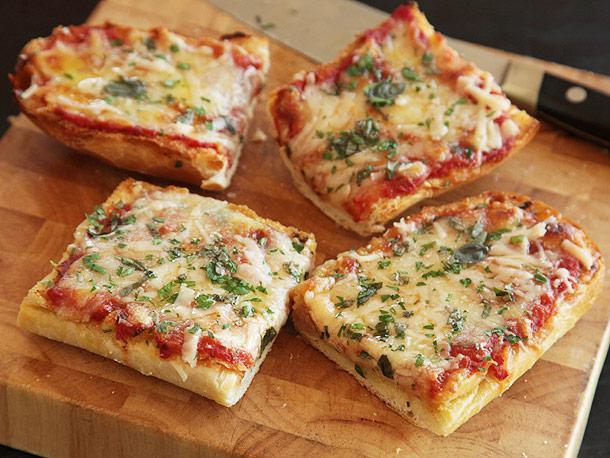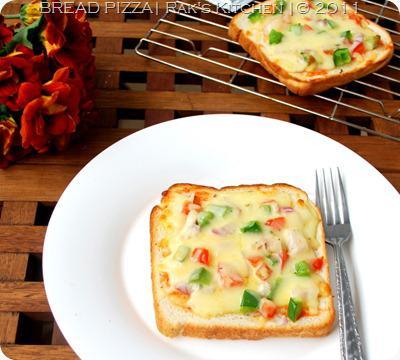The first image is the image on the left, the second image is the image on the right. Analyze the images presented: Is the assertion "One image shows four rectangles covered in red sauce, melted cheese, and green herbs on a wooden board, and the other image includes a topped slice of bread on a white plate." valid? Answer yes or no. Yes. The first image is the image on the left, the second image is the image on the right. Assess this claim about the two images: "In one image, four pieces of french bread pizza are covered with cheese, while a second image shows pizza made with slices of bread used for the crust.". Correct or not? Answer yes or no. Yes. 